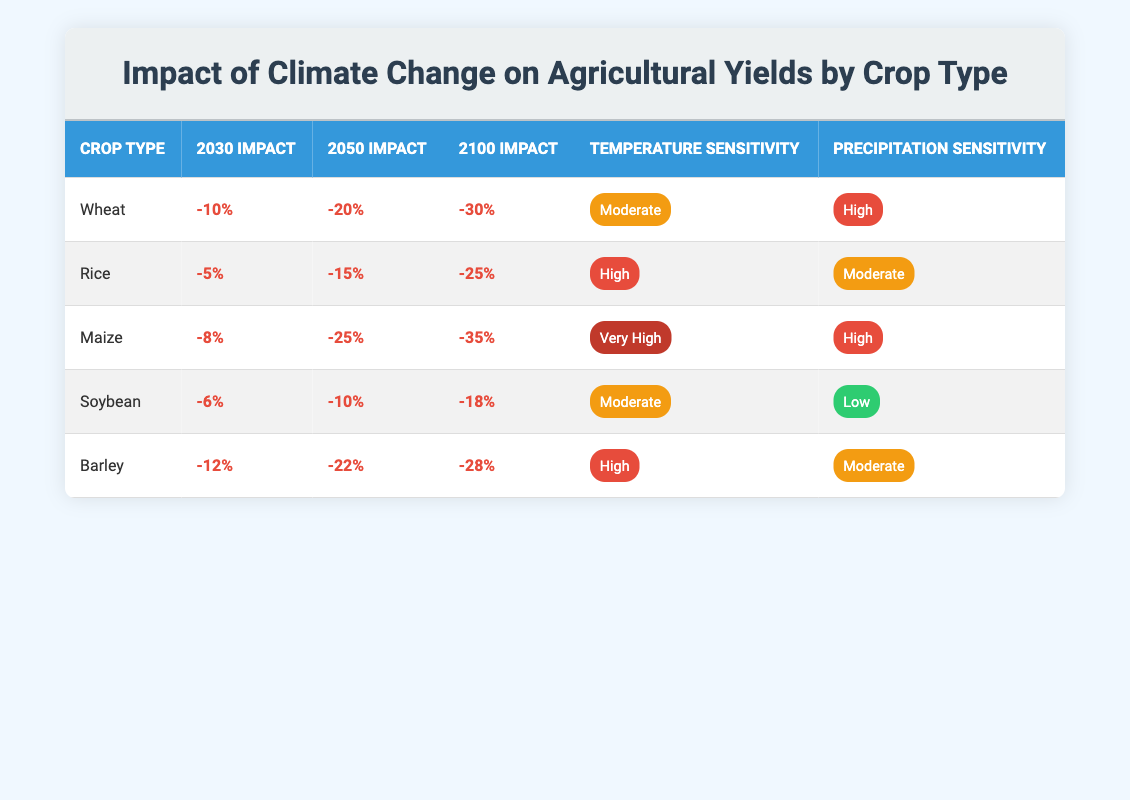What is the projected yield impact on wheat by 2050? The table indicates that the yield impact on wheat for the year 2050 is -20%. This can be directly found in the row corresponding to wheat under the 2050 impact column.
Answer: -20% Which crop has the highest level of temperature sensitivity? From the table, maize shows the highest level of temperature sensitivity, marked as "Very High." It is listed in its corresponding row under the Temperature Sensitivity column.
Answer: Maize What is the average yield impact for rice over the years specified (2030, 2050, 2100)? To find the average yield impact for rice, we first identify the impacts: -5% (2030), -15% (2050), and -25% (2100). Summing these values gives -5 - 15 - 25 = -45. To find the average, we divide -45 by 3 (the number of years), resulting in -15%.
Answer: -15% Is soybean affected more by temperature or precipitation according to the table? Looking at the table, soybean has a temperature sensitivity labeled as "Moderate" and precipitation sensitivity as "Low." Since "Moderate" is higher than "Low," soybean is affected more by temperature.
Answer: Yes, more by temperature Which crop type will face a yield impact of -30% by 2100? By focusing on the 2100 impact column, we can see that the crop type facing a -30% yield impact is wheat, as indicated in its respective row under that column.
Answer: Wheat What is the range of yield impact percentage for barley from 2030 to 2100? For barley, the yield impact percentages are as follows: -12% in 2030, -22% in 2050, and -28% in 2100. The range can be calculated by subtracting the lowest impact (-28%) from the highest (-12%), resulting in a range of -12 - (-28) = 16%.
Answer: 16% Which two crops have a high precipitation sensitivity? The crops that show a high precipitation sensitivity are wheat and maize. By checking the Precipitation Sensitivity column, both are labeled "High."
Answer: Wheat and Maize Does any crop show an increase in yield impact percentage over time? By reviewing the table, all crops show a negative impact percentage that increases with time, indicating a decrease in yields rather than an increase. Therefore, none of the crops show an increase in yield impact percentage.
Answer: No 